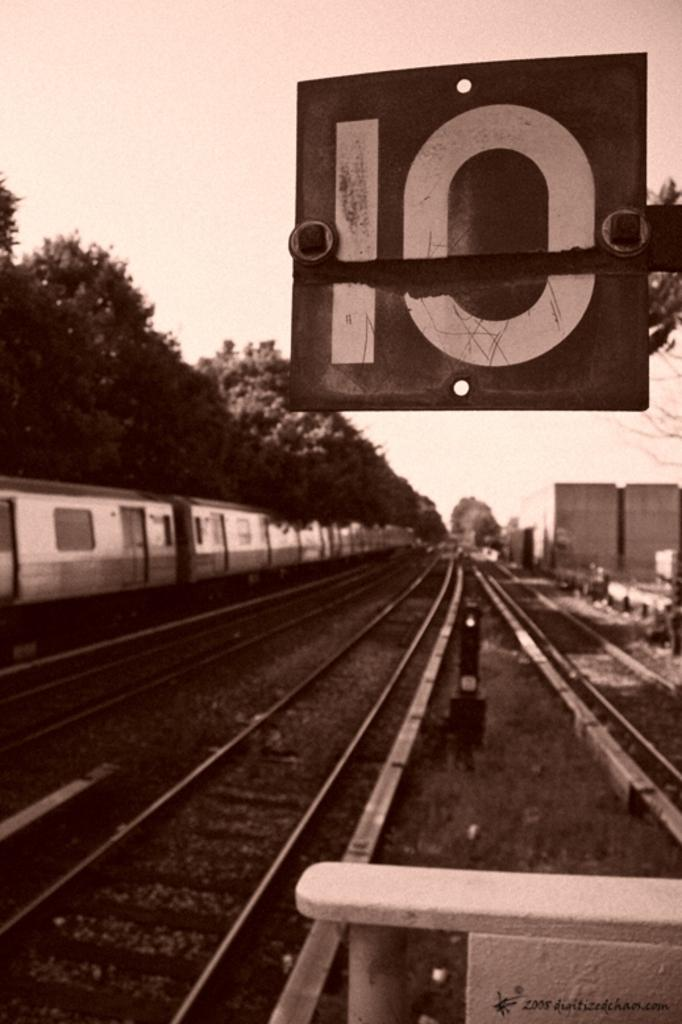Provide a one-sentence caption for the provided image. A sepia toned image of a railroad track with a sign stating that it is track 10. 